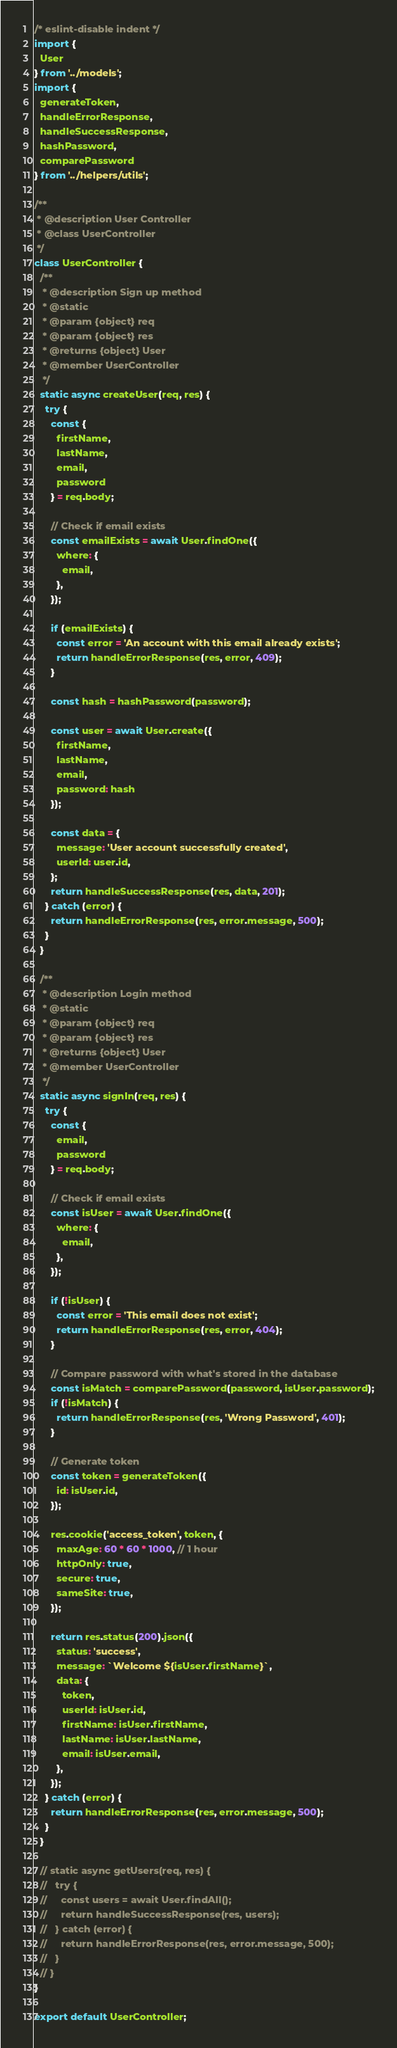<code> <loc_0><loc_0><loc_500><loc_500><_JavaScript_>/* eslint-disable indent */
import {
  User
} from '../models';
import {
  generateToken,
  handleErrorResponse,
  handleSuccessResponse,
  hashPassword,
  comparePassword
} from '../helpers/utils';

/**
 * @description User Controller
 * @class UserController
 */
class UserController {
  /**
   * @description Sign up method
   * @static
   * @param {object} req
   * @param {object} res
   * @returns {object} User
   * @member UserController
   */
  static async createUser(req, res) {
    try {
      const {
        firstName,
        lastName,
        email,
        password
      } = req.body;

      // Check if email exists
      const emailExists = await User.findOne({
        where: {
          email,
        },
      });

      if (emailExists) {
        const error = 'An account with this email already exists';
        return handleErrorResponse(res, error, 409);
      }

      const hash = hashPassword(password);

      const user = await User.create({
        firstName,
        lastName,
        email,
        password: hash
      });

      const data = {
        message: 'User account successfully created',
        userId: user.id,
      };
      return handleSuccessResponse(res, data, 201);
    } catch (error) {
      return handleErrorResponse(res, error.message, 500);
    }
  }

  /**
   * @description Login method
   * @static
   * @param {object} req
   * @param {object} res
   * @returns {object} User
   * @member UserController
   */
  static async signIn(req, res) {
    try {
      const {
        email,
        password
      } = req.body;

      // Check if email exists
      const isUser = await User.findOne({
        where: {
          email,
        },
      });

      if (!isUser) {
        const error = 'This email does not exist';
        return handleErrorResponse(res, error, 404);
      }

      // Compare password with what's stored in the database
      const isMatch = comparePassword(password, isUser.password);
      if (!isMatch) {
        return handleErrorResponse(res, 'Wrong Password', 401);
      }

      // Generate token
      const token = generateToken({
        id: isUser.id,
      });

      res.cookie('access_token', token, {
        maxAge: 60 * 60 * 1000, // 1 hour
        httpOnly: true,
        secure: true,
        sameSite: true,
      });

      return res.status(200).json({
        status: 'success',
        message: `Welcome ${isUser.firstName}`,
        data: {
          token,
          userId: isUser.id,
          firstName: isUser.firstName,
          lastName: isUser.lastName,
          email: isUser.email,
        },
      });
    } catch (error) {
      return handleErrorResponse(res, error.message, 500);
    }
  }

  // static async getUsers(req, res) {
  //   try {
  //     const users = await User.findAll();
  //     return handleSuccessResponse(res, users);
  //   } catch (error) {
  //     return handleErrorResponse(res, error.message, 500);
  //   }
  // }
}

export default UserController;</code> 